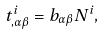Convert formula to latex. <formula><loc_0><loc_0><loc_500><loc_500>t ^ { i } _ { , \alpha \beta } = b _ { \alpha \beta } N ^ { i } ,</formula> 